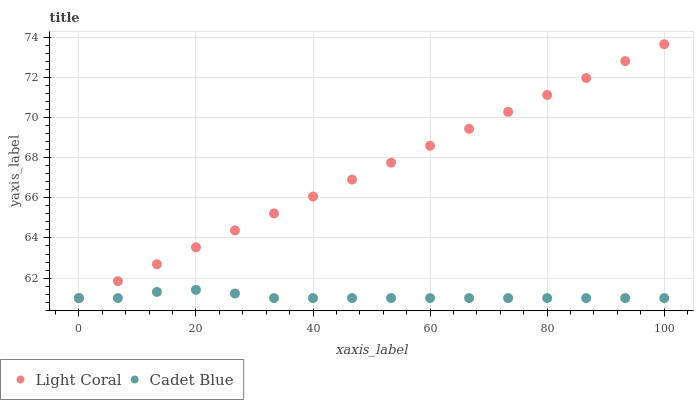Does Cadet Blue have the minimum area under the curve?
Answer yes or no. Yes. Does Light Coral have the maximum area under the curve?
Answer yes or no. Yes. Does Cadet Blue have the maximum area under the curve?
Answer yes or no. No. Is Light Coral the smoothest?
Answer yes or no. Yes. Is Cadet Blue the roughest?
Answer yes or no. Yes. Is Cadet Blue the smoothest?
Answer yes or no. No. Does Light Coral have the lowest value?
Answer yes or no. Yes. Does Light Coral have the highest value?
Answer yes or no. Yes. Does Cadet Blue have the highest value?
Answer yes or no. No. Does Cadet Blue intersect Light Coral?
Answer yes or no. Yes. Is Cadet Blue less than Light Coral?
Answer yes or no. No. Is Cadet Blue greater than Light Coral?
Answer yes or no. No. 